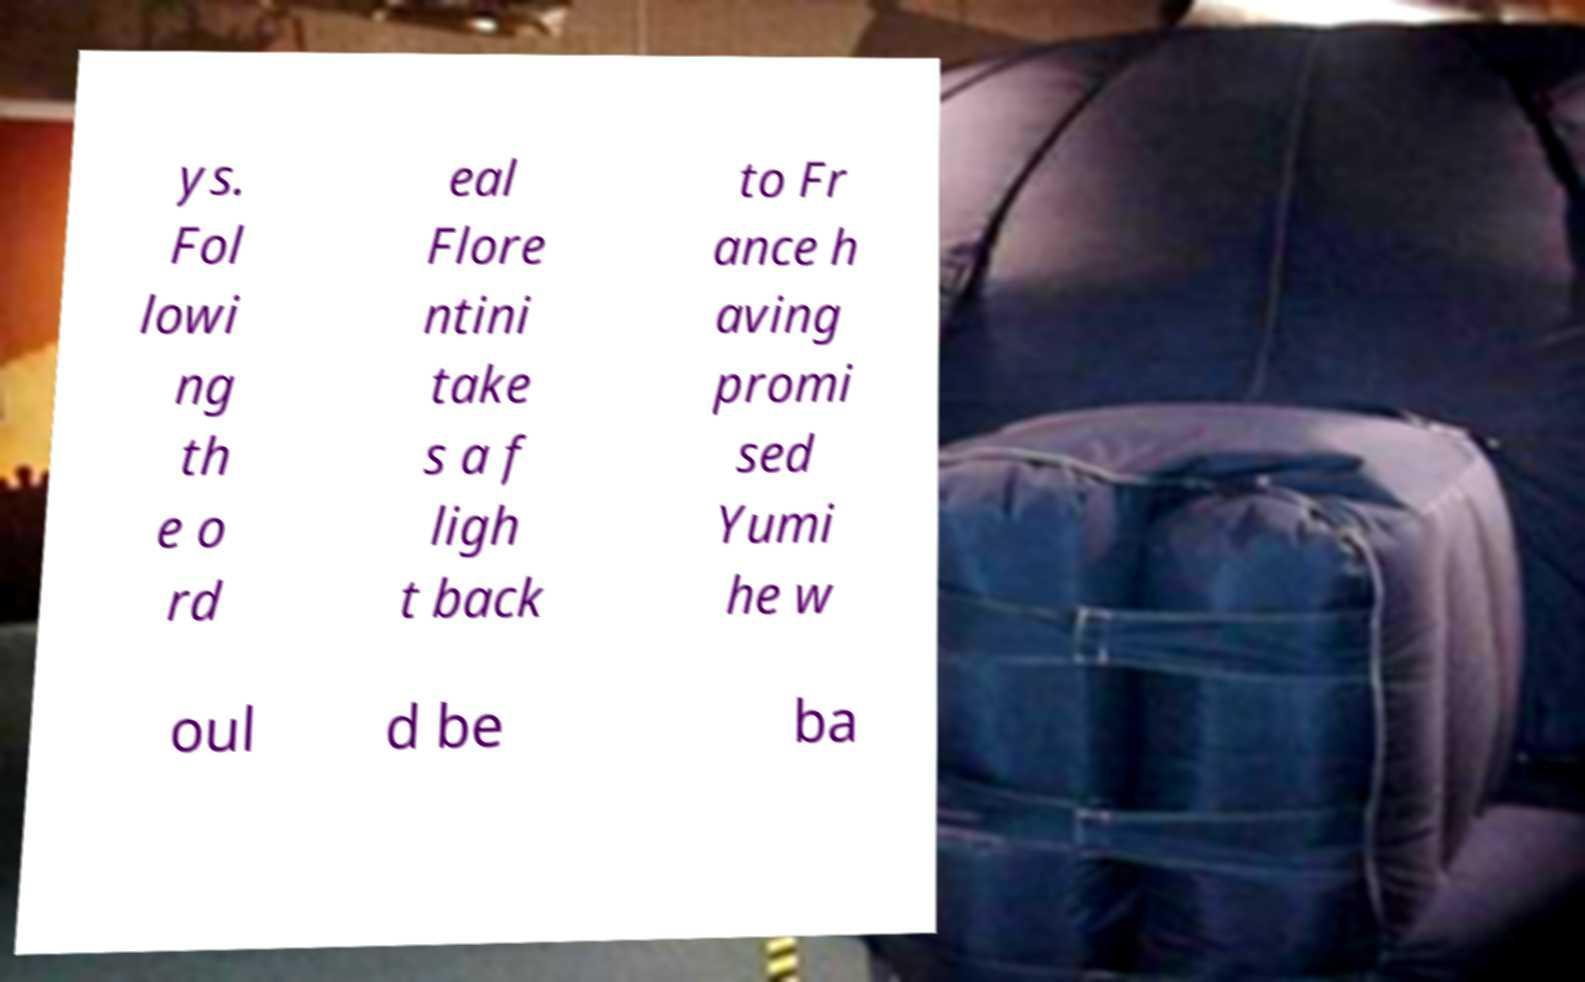I need the written content from this picture converted into text. Can you do that? ys. Fol lowi ng th e o rd eal Flore ntini take s a f ligh t back to Fr ance h aving promi sed Yumi he w oul d be ba 